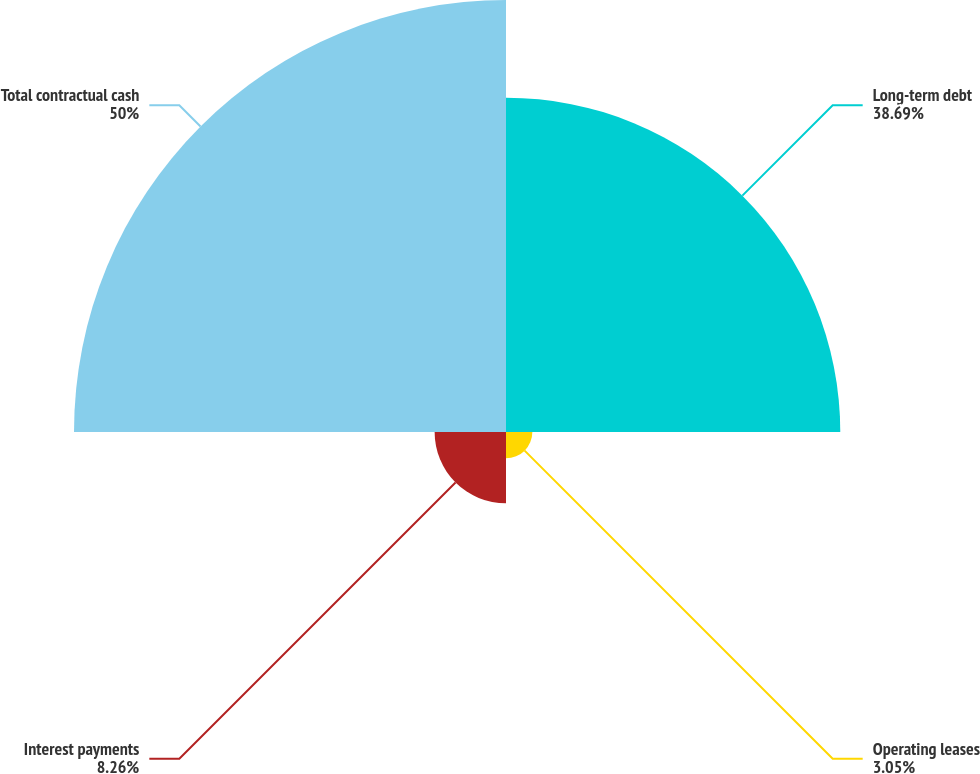Convert chart to OTSL. <chart><loc_0><loc_0><loc_500><loc_500><pie_chart><fcel>Long-term debt<fcel>Operating leases<fcel>Interest payments<fcel>Total contractual cash<nl><fcel>38.69%<fcel>3.05%<fcel>8.26%<fcel>50.0%<nl></chart> 